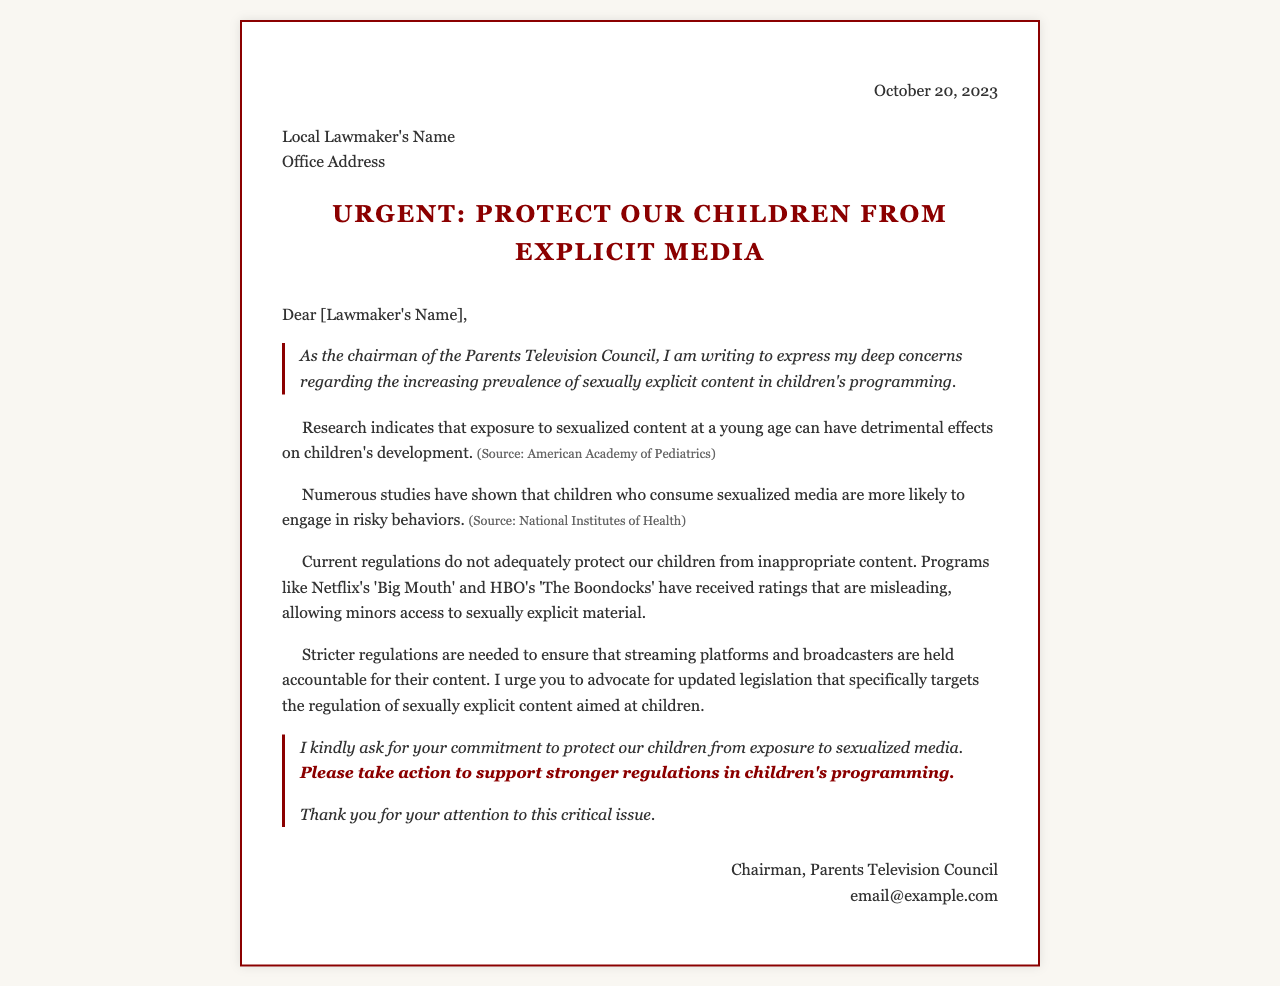What is the date of the letter? The date is stated at the top of the letter, indicating when it was written.
Answer: October 20, 2023 Who is the author of the letter? The author is indicated in the signature section, showing who wrote the letter.
Answer: Chairman, Parents Television Council What is the main concern expressed in the letter? The letter outlines a specific issue based on the concerns of the author regarding children's programming.
Answer: Sexually explicit content Which two programs are mentioned as examples of inappropriate content? The letter provides specific examples to highlight the concerns being discussed.
Answer: Big Mouth and The Boondocks What organization is cited as a source for research on the effects of sexualized content? The letter references specific authorities to support its claims about the issue.
Answer: American Academy of Pediatrics What action is the author urging the lawmakers to take? The letter contains a direct appeal to the recipients, highlighting what the author expects from them.
Answer: Advocate for updated legislation What type of content does the letter specifically focus on? The subject matter of the letter is made clear in the opening and throughout the body.
Answer: Children's programming What is the style of the conclusion in the letter? The conclusion contains elements that summarize the urgency and the author's request.
Answer: Call to action 